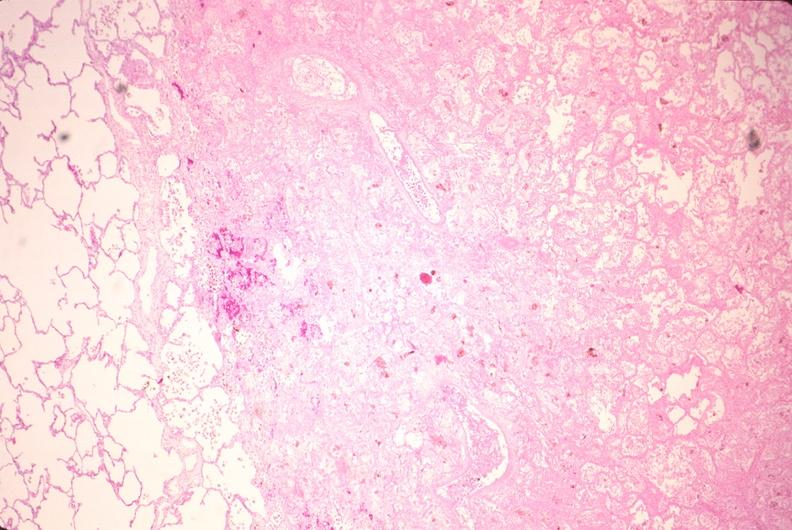what is present?
Answer the question using a single word or phrase. Respiratory 